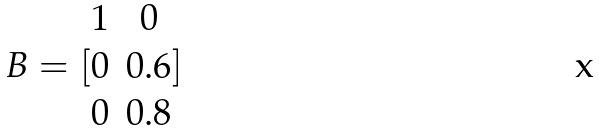Convert formula to latex. <formula><loc_0><loc_0><loc_500><loc_500>B = [ \begin{matrix} 1 & 0 \\ 0 & 0 . 6 \\ 0 & 0 . 8 \end{matrix} ]</formula> 